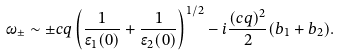<formula> <loc_0><loc_0><loc_500><loc_500>\omega _ { \pm } \sim \pm c q \left ( \frac { 1 } { \epsilon _ { 1 } ( 0 ) } + \frac { 1 } { \epsilon _ { 2 } ( 0 ) } \right ) ^ { 1 / 2 } - i \frac { ( c q ) ^ { 2 } } { 2 } ( b _ { 1 } + b _ { 2 } ) .</formula> 